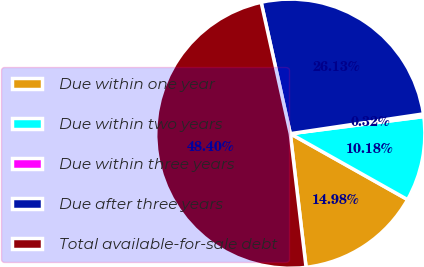Convert chart to OTSL. <chart><loc_0><loc_0><loc_500><loc_500><pie_chart><fcel>Due within one year<fcel>Due within two years<fcel>Due within three years<fcel>Due after three years<fcel>Total available-for-sale debt<nl><fcel>14.98%<fcel>10.18%<fcel>0.32%<fcel>26.13%<fcel>48.4%<nl></chart> 